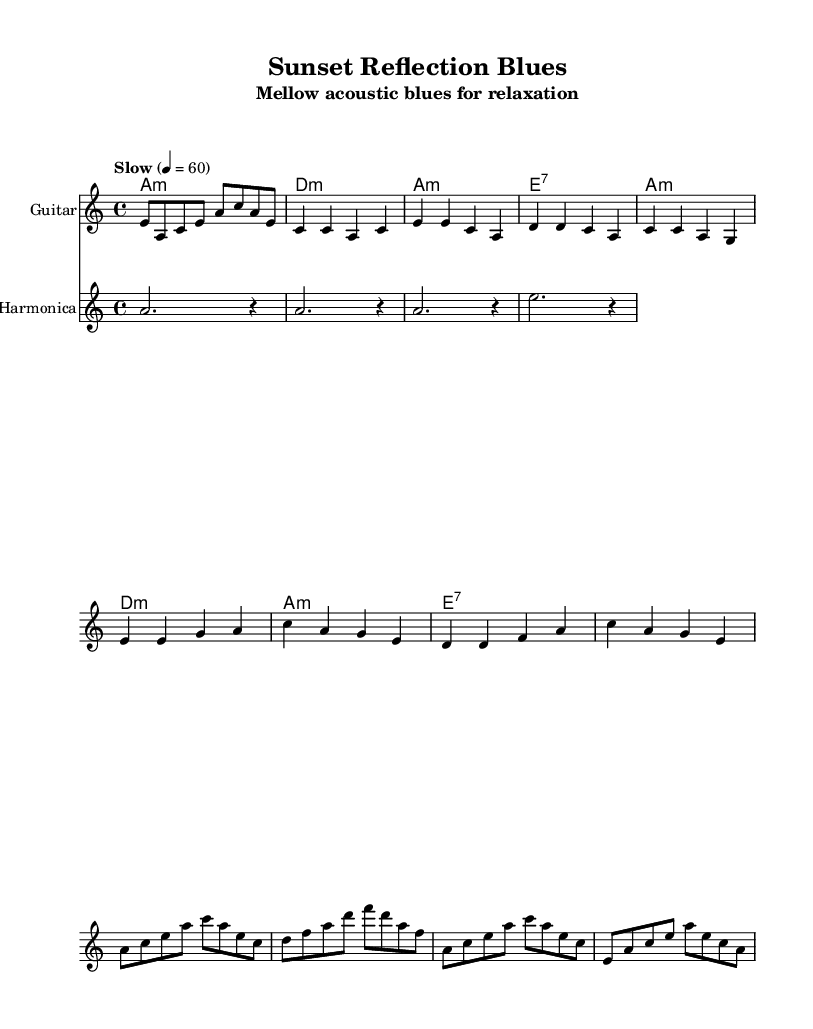What is the key signature of this music? The key signature is indicated by the presence of two flat symbols in the music staff. This corresponds to the key of A minor, which is the relative minor of C major and contains no sharps or flats.
Answer: A minor What is the time signature indicated in the piece? The time signature is found at the beginning of the staff, represented by the two numbers stacked on top of each other. In this case, it shows a 4 on the top and a 4 on the bottom, which means there are four beats in a measure and each quarter note gets one beat.
Answer: 4/4 What is the tempo marking of the music? The tempo marking is usually specified above the staff and indicates the speed of the music. Here, it is shown as "Slow" with a metronome marking of 60, meaning there are 60 beats per minute.
Answer: Slow 4 = 60 Which instrument is playing the chords? The instrument assigned to play the chords is indicated in the staff’s instrument name section. In this case, it is labeled as "Guitar."
Answer: Guitar How many measures are in the Chorus section? To determine the number of measures in the Chorus, we count the individual segments separated by vertical lines (bar lines) within the Chorus notation. Counting these segments reveals that there are four measures in the Chorus section.
Answer: 4 What is the primary function of the harmonica in this piece? The harmonica in this music serves to add sustained notes, providing a complementary sound to the guitar melody. It plays longer notes, creating a background effect and enhancing the overall blues feel of the piece.
Answer: Sustained notes 